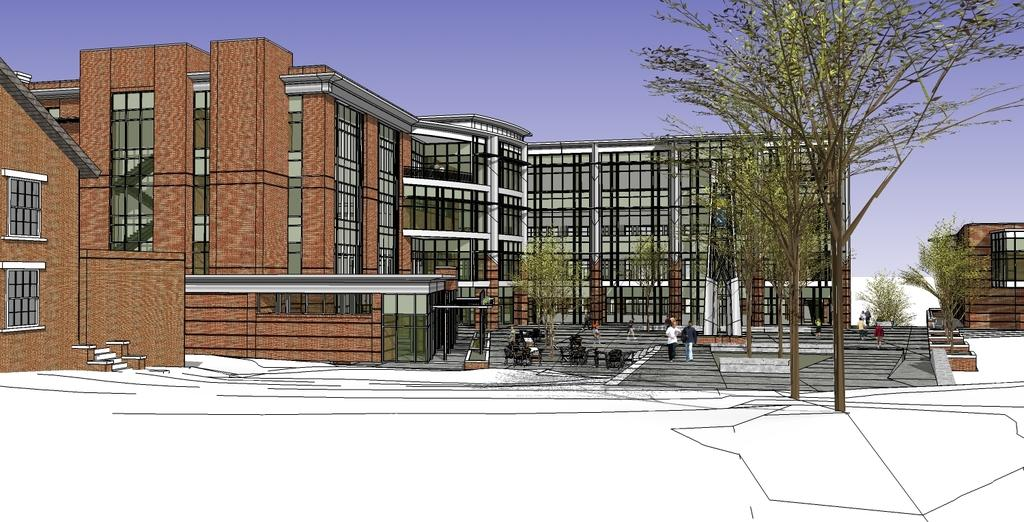What type of artwork is depicted in the image? The image is a painting. What structures are present in the painting? There are buildings with windows in the painting. What type of vegetation is in the painting? There are trees in the painting. What are the two people in the painting doing? Two people are walking in the painting. What can be seen in the background of the painting? There is sky visible in the background of the painting. What musical instrument is being played by the trees in the painting? There are no musical instruments being played by the trees in the painting; trees do not play musical instruments. 